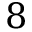Convert formula to latex. <formula><loc_0><loc_0><loc_500><loc_500>8</formula> 